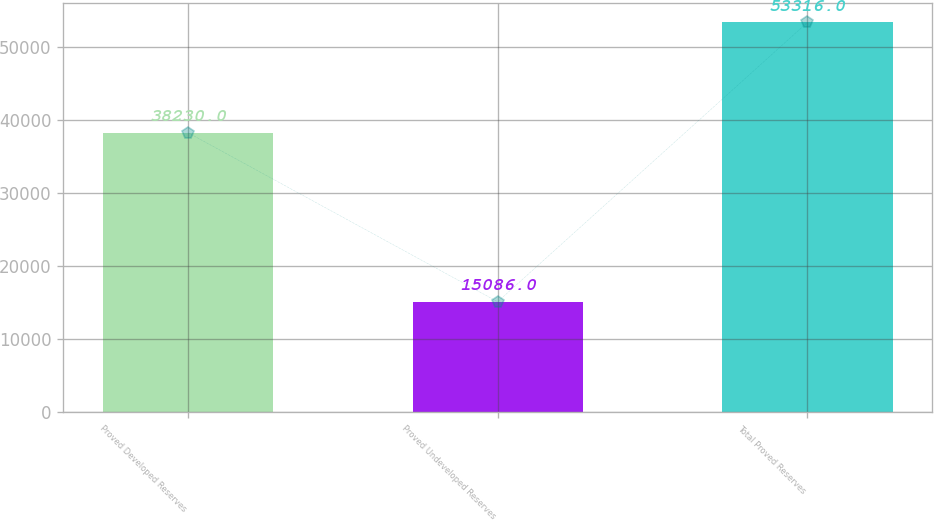<chart> <loc_0><loc_0><loc_500><loc_500><bar_chart><fcel>Proved Developed Reserves<fcel>Proved Undeveloped Reserves<fcel>Total Proved Reserves<nl><fcel>38230<fcel>15086<fcel>53316<nl></chart> 